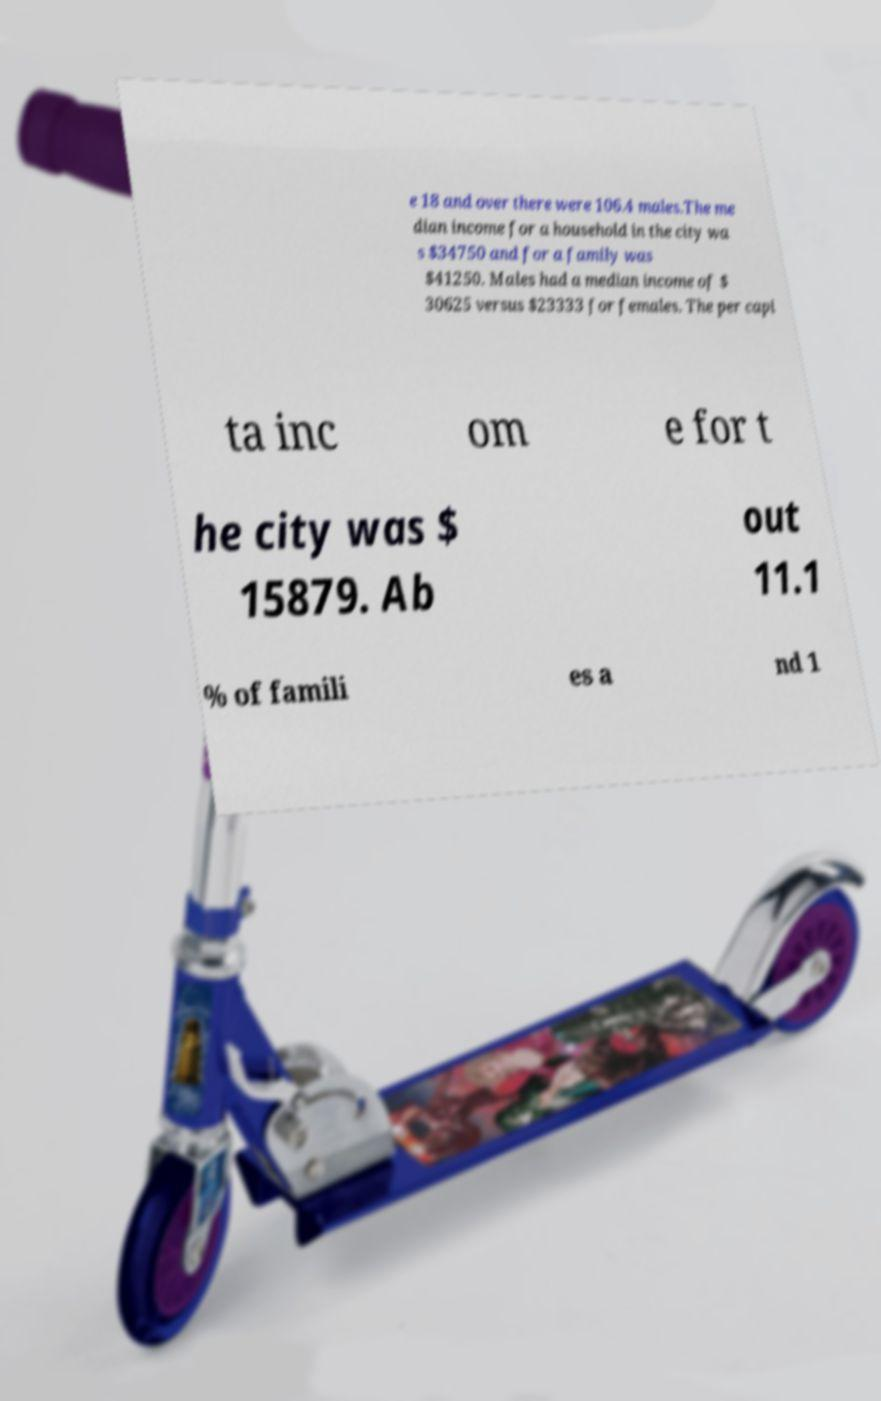Could you extract and type out the text from this image? e 18 and over there were 106.4 males.The me dian income for a household in the city wa s $34750 and for a family was $41250. Males had a median income of $ 30625 versus $23333 for females. The per capi ta inc om e for t he city was $ 15879. Ab out 11.1 % of famili es a nd 1 